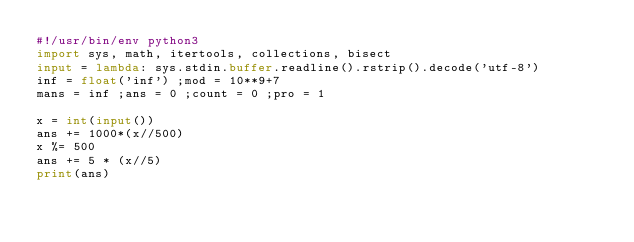Convert code to text. <code><loc_0><loc_0><loc_500><loc_500><_Python_>#!/usr/bin/env python3
import sys, math, itertools, collections, bisect
input = lambda: sys.stdin.buffer.readline().rstrip().decode('utf-8')
inf = float('inf') ;mod = 10**9+7
mans = inf ;ans = 0 ;count = 0 ;pro = 1

x = int(input())
ans += 1000*(x//500)
x %= 500
ans += 5 * (x//5)
print(ans)</code> 